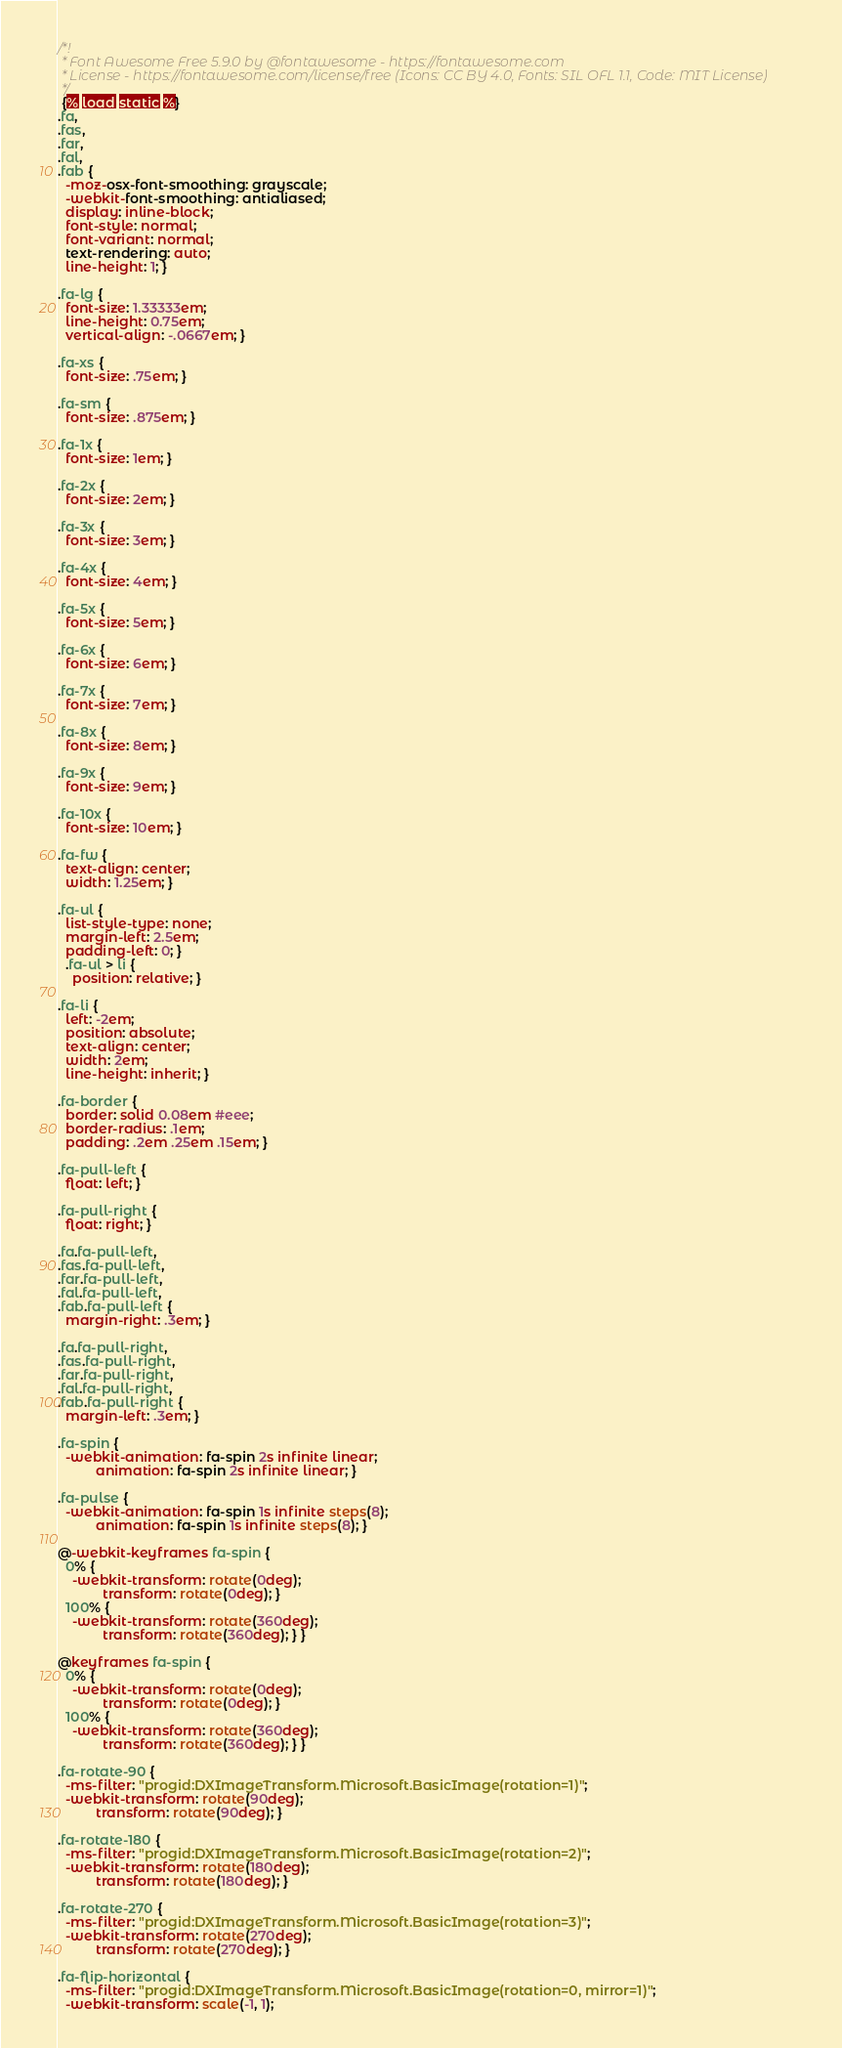Convert code to text. <code><loc_0><loc_0><loc_500><loc_500><_CSS_>/*!
 * Font Awesome Free 5.9.0 by @fontawesome - https://fontawesome.com
 * License - https://fontawesome.com/license/free (Icons: CC BY 4.0, Fonts: SIL OFL 1.1, Code: MIT License)
 */
 {% load static %}
.fa,
.fas,
.far,
.fal,
.fab {
  -moz-osx-font-smoothing: grayscale;
  -webkit-font-smoothing: antialiased;
  display: inline-block;
  font-style: normal;
  font-variant: normal;
  text-rendering: auto;
  line-height: 1; }

.fa-lg {
  font-size: 1.33333em;
  line-height: 0.75em;
  vertical-align: -.0667em; }

.fa-xs {
  font-size: .75em; }

.fa-sm {
  font-size: .875em; }

.fa-1x {
  font-size: 1em; }

.fa-2x {
  font-size: 2em; }

.fa-3x {
  font-size: 3em; }

.fa-4x {
  font-size: 4em; }

.fa-5x {
  font-size: 5em; }

.fa-6x {
  font-size: 6em; }

.fa-7x {
  font-size: 7em; }

.fa-8x {
  font-size: 8em; }

.fa-9x {
  font-size: 9em; }

.fa-10x {
  font-size: 10em; }

.fa-fw {
  text-align: center;
  width: 1.25em; }

.fa-ul {
  list-style-type: none;
  margin-left: 2.5em;
  padding-left: 0; }
  .fa-ul > li {
    position: relative; }

.fa-li {
  left: -2em;
  position: absolute;
  text-align: center;
  width: 2em;
  line-height: inherit; }

.fa-border {
  border: solid 0.08em #eee;
  border-radius: .1em;
  padding: .2em .25em .15em; }

.fa-pull-left {
  float: left; }

.fa-pull-right {
  float: right; }

.fa.fa-pull-left,
.fas.fa-pull-left,
.far.fa-pull-left,
.fal.fa-pull-left,
.fab.fa-pull-left {
  margin-right: .3em; }

.fa.fa-pull-right,
.fas.fa-pull-right,
.far.fa-pull-right,
.fal.fa-pull-right,
.fab.fa-pull-right {
  margin-left: .3em; }

.fa-spin {
  -webkit-animation: fa-spin 2s infinite linear;
          animation: fa-spin 2s infinite linear; }

.fa-pulse {
  -webkit-animation: fa-spin 1s infinite steps(8);
          animation: fa-spin 1s infinite steps(8); }

@-webkit-keyframes fa-spin {
  0% {
    -webkit-transform: rotate(0deg);
            transform: rotate(0deg); }
  100% {
    -webkit-transform: rotate(360deg);
            transform: rotate(360deg); } }

@keyframes fa-spin {
  0% {
    -webkit-transform: rotate(0deg);
            transform: rotate(0deg); }
  100% {
    -webkit-transform: rotate(360deg);
            transform: rotate(360deg); } }

.fa-rotate-90 {
  -ms-filter: "progid:DXImageTransform.Microsoft.BasicImage(rotation=1)";
  -webkit-transform: rotate(90deg);
          transform: rotate(90deg); }

.fa-rotate-180 {
  -ms-filter: "progid:DXImageTransform.Microsoft.BasicImage(rotation=2)";
  -webkit-transform: rotate(180deg);
          transform: rotate(180deg); }

.fa-rotate-270 {
  -ms-filter: "progid:DXImageTransform.Microsoft.BasicImage(rotation=3)";
  -webkit-transform: rotate(270deg);
          transform: rotate(270deg); }

.fa-flip-horizontal {
  -ms-filter: "progid:DXImageTransform.Microsoft.BasicImage(rotation=0, mirror=1)";
  -webkit-transform: scale(-1, 1);</code> 